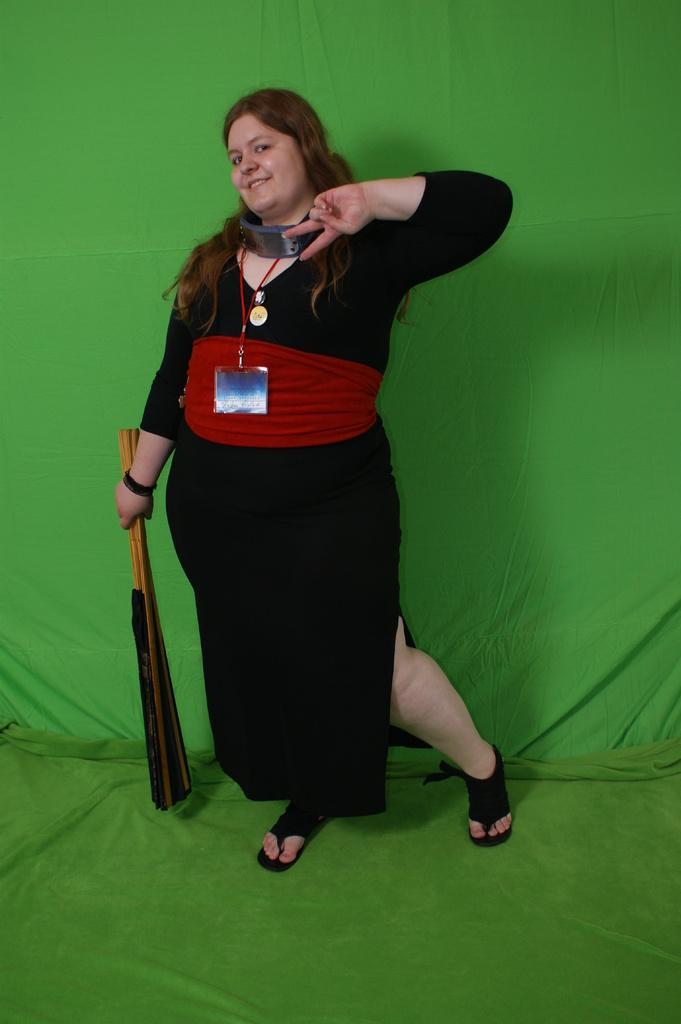What is the main subject of the image? The main subject of the image is a lady. What is the lady holding in the image? The lady is holding an object. Can you describe the color of the mat in the image? There is a green-colored mat in the image. What type of mine can be seen in the image? There is no mine present in the image. What type of coat is the secretary wearing in the image? There is no secretary or coat present in the image. 